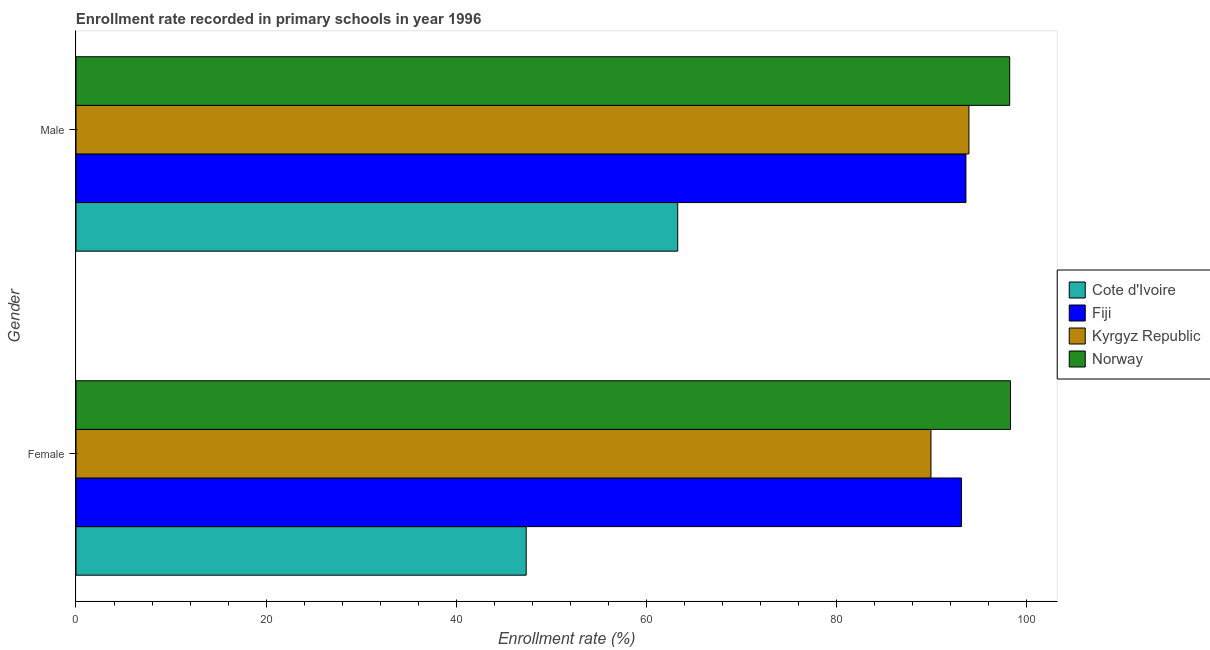How many groups of bars are there?
Your answer should be very brief. 2. Are the number of bars per tick equal to the number of legend labels?
Offer a terse response. Yes. Are the number of bars on each tick of the Y-axis equal?
Provide a short and direct response. Yes. How many bars are there on the 1st tick from the bottom?
Your answer should be compact. 4. What is the enrollment rate of male students in Kyrgyz Republic?
Your response must be concise. 93.97. Across all countries, what is the maximum enrollment rate of female students?
Provide a short and direct response. 98.34. Across all countries, what is the minimum enrollment rate of male students?
Make the answer very short. 63.32. In which country was the enrollment rate of male students minimum?
Give a very brief answer. Cote d'Ivoire. What is the total enrollment rate of male students in the graph?
Your answer should be very brief. 349.2. What is the difference between the enrollment rate of female students in Fiji and that in Norway?
Your answer should be compact. -5.16. What is the difference between the enrollment rate of male students in Norway and the enrollment rate of female students in Cote d'Ivoire?
Offer a terse response. 50.88. What is the average enrollment rate of female students per country?
Give a very brief answer. 82.22. What is the difference between the enrollment rate of female students and enrollment rate of male students in Kyrgyz Republic?
Keep it short and to the point. -4. In how many countries, is the enrollment rate of male students greater than 92 %?
Make the answer very short. 3. What is the ratio of the enrollment rate of female students in Kyrgyz Republic to that in Norway?
Your answer should be compact. 0.91. Is the enrollment rate of male students in Fiji less than that in Norway?
Offer a terse response. Yes. In how many countries, is the enrollment rate of male students greater than the average enrollment rate of male students taken over all countries?
Provide a short and direct response. 3. What does the 1st bar from the top in Female represents?
Offer a very short reply. Norway. What does the 1st bar from the bottom in Male represents?
Give a very brief answer. Cote d'Ivoire. Are all the bars in the graph horizontal?
Your response must be concise. Yes. What is the difference between two consecutive major ticks on the X-axis?
Ensure brevity in your answer.  20. Does the graph contain any zero values?
Offer a very short reply. No. Does the graph contain grids?
Give a very brief answer. No. Where does the legend appear in the graph?
Ensure brevity in your answer.  Center right. How many legend labels are there?
Offer a very short reply. 4. How are the legend labels stacked?
Provide a succinct answer. Vertical. What is the title of the graph?
Provide a short and direct response. Enrollment rate recorded in primary schools in year 1996. Does "Mozambique" appear as one of the legend labels in the graph?
Make the answer very short. No. What is the label or title of the X-axis?
Keep it short and to the point. Enrollment rate (%). What is the label or title of the Y-axis?
Offer a terse response. Gender. What is the Enrollment rate (%) in Cote d'Ivoire in Female?
Give a very brief answer. 47.38. What is the Enrollment rate (%) of Fiji in Female?
Give a very brief answer. 93.18. What is the Enrollment rate (%) in Kyrgyz Republic in Female?
Keep it short and to the point. 89.97. What is the Enrollment rate (%) of Norway in Female?
Ensure brevity in your answer.  98.34. What is the Enrollment rate (%) in Cote d'Ivoire in Male?
Keep it short and to the point. 63.32. What is the Enrollment rate (%) of Fiji in Male?
Your answer should be very brief. 93.65. What is the Enrollment rate (%) in Kyrgyz Republic in Male?
Make the answer very short. 93.97. What is the Enrollment rate (%) in Norway in Male?
Provide a short and direct response. 98.26. Across all Gender, what is the maximum Enrollment rate (%) of Cote d'Ivoire?
Keep it short and to the point. 63.32. Across all Gender, what is the maximum Enrollment rate (%) of Fiji?
Your answer should be compact. 93.65. Across all Gender, what is the maximum Enrollment rate (%) of Kyrgyz Republic?
Your response must be concise. 93.97. Across all Gender, what is the maximum Enrollment rate (%) in Norway?
Make the answer very short. 98.34. Across all Gender, what is the minimum Enrollment rate (%) of Cote d'Ivoire?
Give a very brief answer. 47.38. Across all Gender, what is the minimum Enrollment rate (%) of Fiji?
Offer a terse response. 93.18. Across all Gender, what is the minimum Enrollment rate (%) in Kyrgyz Republic?
Offer a very short reply. 89.97. Across all Gender, what is the minimum Enrollment rate (%) in Norway?
Offer a terse response. 98.26. What is the total Enrollment rate (%) in Cote d'Ivoire in the graph?
Offer a very short reply. 110.7. What is the total Enrollment rate (%) in Fiji in the graph?
Your answer should be compact. 186.84. What is the total Enrollment rate (%) in Kyrgyz Republic in the graph?
Provide a short and direct response. 183.94. What is the total Enrollment rate (%) in Norway in the graph?
Your response must be concise. 196.6. What is the difference between the Enrollment rate (%) in Cote d'Ivoire in Female and that in Male?
Provide a succinct answer. -15.95. What is the difference between the Enrollment rate (%) in Fiji in Female and that in Male?
Provide a short and direct response. -0.47. What is the difference between the Enrollment rate (%) of Kyrgyz Republic in Female and that in Male?
Offer a terse response. -4. What is the difference between the Enrollment rate (%) in Norway in Female and that in Male?
Offer a very short reply. 0.09. What is the difference between the Enrollment rate (%) in Cote d'Ivoire in Female and the Enrollment rate (%) in Fiji in Male?
Provide a short and direct response. -46.28. What is the difference between the Enrollment rate (%) of Cote d'Ivoire in Female and the Enrollment rate (%) of Kyrgyz Republic in Male?
Your answer should be compact. -46.59. What is the difference between the Enrollment rate (%) in Cote d'Ivoire in Female and the Enrollment rate (%) in Norway in Male?
Offer a terse response. -50.88. What is the difference between the Enrollment rate (%) in Fiji in Female and the Enrollment rate (%) in Kyrgyz Republic in Male?
Provide a short and direct response. -0.79. What is the difference between the Enrollment rate (%) in Fiji in Female and the Enrollment rate (%) in Norway in Male?
Give a very brief answer. -5.07. What is the difference between the Enrollment rate (%) of Kyrgyz Republic in Female and the Enrollment rate (%) of Norway in Male?
Give a very brief answer. -8.28. What is the average Enrollment rate (%) of Cote d'Ivoire per Gender?
Keep it short and to the point. 55.35. What is the average Enrollment rate (%) of Fiji per Gender?
Provide a short and direct response. 93.42. What is the average Enrollment rate (%) of Kyrgyz Republic per Gender?
Keep it short and to the point. 91.97. What is the average Enrollment rate (%) in Norway per Gender?
Offer a terse response. 98.3. What is the difference between the Enrollment rate (%) in Cote d'Ivoire and Enrollment rate (%) in Fiji in Female?
Your answer should be very brief. -45.81. What is the difference between the Enrollment rate (%) in Cote d'Ivoire and Enrollment rate (%) in Kyrgyz Republic in Female?
Provide a succinct answer. -42.6. What is the difference between the Enrollment rate (%) in Cote d'Ivoire and Enrollment rate (%) in Norway in Female?
Your answer should be very brief. -50.97. What is the difference between the Enrollment rate (%) of Fiji and Enrollment rate (%) of Kyrgyz Republic in Female?
Your response must be concise. 3.21. What is the difference between the Enrollment rate (%) in Fiji and Enrollment rate (%) in Norway in Female?
Ensure brevity in your answer.  -5.16. What is the difference between the Enrollment rate (%) of Kyrgyz Republic and Enrollment rate (%) of Norway in Female?
Provide a succinct answer. -8.37. What is the difference between the Enrollment rate (%) in Cote d'Ivoire and Enrollment rate (%) in Fiji in Male?
Your answer should be compact. -30.33. What is the difference between the Enrollment rate (%) in Cote d'Ivoire and Enrollment rate (%) in Kyrgyz Republic in Male?
Offer a terse response. -30.65. What is the difference between the Enrollment rate (%) of Cote d'Ivoire and Enrollment rate (%) of Norway in Male?
Offer a very short reply. -34.93. What is the difference between the Enrollment rate (%) in Fiji and Enrollment rate (%) in Kyrgyz Republic in Male?
Ensure brevity in your answer.  -0.32. What is the difference between the Enrollment rate (%) of Fiji and Enrollment rate (%) of Norway in Male?
Your answer should be compact. -4.6. What is the difference between the Enrollment rate (%) of Kyrgyz Republic and Enrollment rate (%) of Norway in Male?
Your response must be concise. -4.29. What is the ratio of the Enrollment rate (%) in Cote d'Ivoire in Female to that in Male?
Ensure brevity in your answer.  0.75. What is the ratio of the Enrollment rate (%) of Kyrgyz Republic in Female to that in Male?
Ensure brevity in your answer.  0.96. What is the difference between the highest and the second highest Enrollment rate (%) in Cote d'Ivoire?
Give a very brief answer. 15.95. What is the difference between the highest and the second highest Enrollment rate (%) of Fiji?
Give a very brief answer. 0.47. What is the difference between the highest and the second highest Enrollment rate (%) of Kyrgyz Republic?
Offer a terse response. 4. What is the difference between the highest and the second highest Enrollment rate (%) of Norway?
Your response must be concise. 0.09. What is the difference between the highest and the lowest Enrollment rate (%) in Cote d'Ivoire?
Your response must be concise. 15.95. What is the difference between the highest and the lowest Enrollment rate (%) in Fiji?
Your answer should be very brief. 0.47. What is the difference between the highest and the lowest Enrollment rate (%) of Kyrgyz Republic?
Your answer should be compact. 4. What is the difference between the highest and the lowest Enrollment rate (%) in Norway?
Your answer should be very brief. 0.09. 